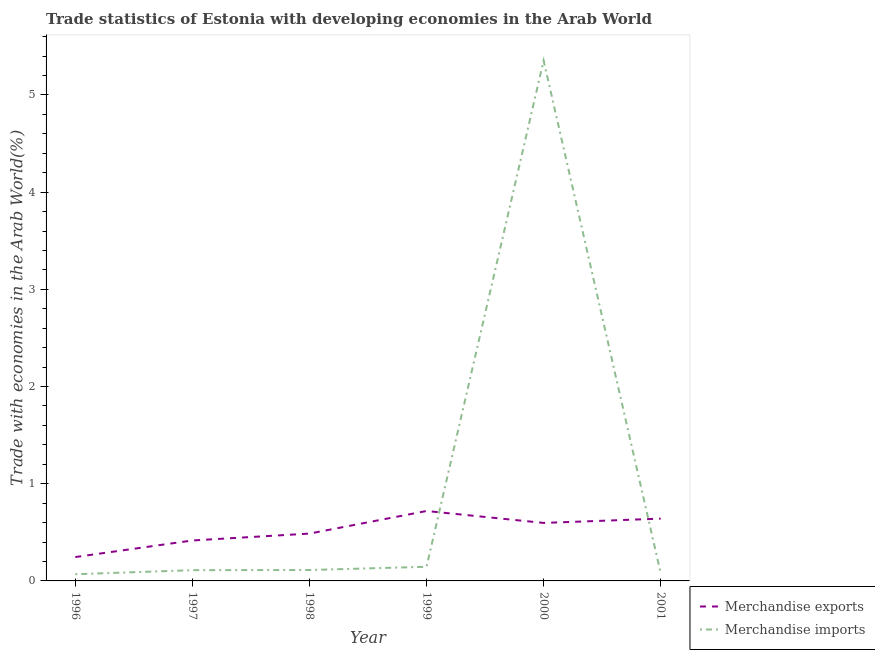How many different coloured lines are there?
Offer a terse response. 2. Does the line corresponding to merchandise exports intersect with the line corresponding to merchandise imports?
Give a very brief answer. Yes. Is the number of lines equal to the number of legend labels?
Keep it short and to the point. Yes. What is the merchandise exports in 2001?
Keep it short and to the point. 0.64. Across all years, what is the maximum merchandise exports?
Give a very brief answer. 0.72. Across all years, what is the minimum merchandise exports?
Your answer should be compact. 0.25. What is the total merchandise exports in the graph?
Provide a succinct answer. 3.11. What is the difference between the merchandise imports in 1996 and that in 2001?
Provide a short and direct response. -0.01. What is the difference between the merchandise imports in 1998 and the merchandise exports in 2000?
Offer a terse response. -0.48. What is the average merchandise exports per year?
Make the answer very short. 0.52. In the year 1999, what is the difference between the merchandise exports and merchandise imports?
Your response must be concise. 0.57. In how many years, is the merchandise imports greater than 3.8 %?
Offer a terse response. 1. What is the ratio of the merchandise imports in 1996 to that in 2000?
Offer a terse response. 0.01. Is the merchandise imports in 1998 less than that in 1999?
Keep it short and to the point. Yes. What is the difference between the highest and the second highest merchandise exports?
Offer a very short reply. 0.08. What is the difference between the highest and the lowest merchandise exports?
Provide a short and direct response. 0.47. Does the merchandise exports monotonically increase over the years?
Your response must be concise. No. Is the merchandise exports strictly less than the merchandise imports over the years?
Give a very brief answer. No. How many lines are there?
Provide a succinct answer. 2. How many years are there in the graph?
Your answer should be very brief. 6. What is the difference between two consecutive major ticks on the Y-axis?
Your answer should be compact. 1. Does the graph contain grids?
Make the answer very short. No. Where does the legend appear in the graph?
Offer a very short reply. Bottom right. How many legend labels are there?
Your response must be concise. 2. What is the title of the graph?
Keep it short and to the point. Trade statistics of Estonia with developing economies in the Arab World. What is the label or title of the Y-axis?
Give a very brief answer. Trade with economies in the Arab World(%). What is the Trade with economies in the Arab World(%) of Merchandise exports in 1996?
Offer a terse response. 0.25. What is the Trade with economies in the Arab World(%) in Merchandise imports in 1996?
Make the answer very short. 0.07. What is the Trade with economies in the Arab World(%) in Merchandise exports in 1997?
Your answer should be compact. 0.42. What is the Trade with economies in the Arab World(%) of Merchandise imports in 1997?
Your answer should be compact. 0.11. What is the Trade with economies in the Arab World(%) of Merchandise exports in 1998?
Offer a very short reply. 0.49. What is the Trade with economies in the Arab World(%) of Merchandise imports in 1998?
Provide a succinct answer. 0.11. What is the Trade with economies in the Arab World(%) in Merchandise exports in 1999?
Your answer should be very brief. 0.72. What is the Trade with economies in the Arab World(%) in Merchandise imports in 1999?
Make the answer very short. 0.15. What is the Trade with economies in the Arab World(%) of Merchandise exports in 2000?
Your answer should be very brief. 0.6. What is the Trade with economies in the Arab World(%) of Merchandise imports in 2000?
Offer a very short reply. 5.35. What is the Trade with economies in the Arab World(%) of Merchandise exports in 2001?
Your answer should be very brief. 0.64. What is the Trade with economies in the Arab World(%) of Merchandise imports in 2001?
Your response must be concise. 0.08. Across all years, what is the maximum Trade with economies in the Arab World(%) in Merchandise exports?
Offer a terse response. 0.72. Across all years, what is the maximum Trade with economies in the Arab World(%) of Merchandise imports?
Ensure brevity in your answer.  5.35. Across all years, what is the minimum Trade with economies in the Arab World(%) of Merchandise exports?
Provide a succinct answer. 0.25. Across all years, what is the minimum Trade with economies in the Arab World(%) in Merchandise imports?
Your answer should be compact. 0.07. What is the total Trade with economies in the Arab World(%) in Merchandise exports in the graph?
Your answer should be compact. 3.11. What is the total Trade with economies in the Arab World(%) in Merchandise imports in the graph?
Provide a succinct answer. 5.87. What is the difference between the Trade with economies in the Arab World(%) in Merchandise exports in 1996 and that in 1997?
Give a very brief answer. -0.17. What is the difference between the Trade with economies in the Arab World(%) of Merchandise imports in 1996 and that in 1997?
Provide a succinct answer. -0.04. What is the difference between the Trade with economies in the Arab World(%) in Merchandise exports in 1996 and that in 1998?
Your answer should be compact. -0.24. What is the difference between the Trade with economies in the Arab World(%) of Merchandise imports in 1996 and that in 1998?
Provide a succinct answer. -0.04. What is the difference between the Trade with economies in the Arab World(%) in Merchandise exports in 1996 and that in 1999?
Offer a terse response. -0.47. What is the difference between the Trade with economies in the Arab World(%) of Merchandise imports in 1996 and that in 1999?
Make the answer very short. -0.08. What is the difference between the Trade with economies in the Arab World(%) in Merchandise exports in 1996 and that in 2000?
Provide a succinct answer. -0.35. What is the difference between the Trade with economies in the Arab World(%) of Merchandise imports in 1996 and that in 2000?
Make the answer very short. -5.29. What is the difference between the Trade with economies in the Arab World(%) in Merchandise exports in 1996 and that in 2001?
Provide a succinct answer. -0.4. What is the difference between the Trade with economies in the Arab World(%) in Merchandise imports in 1996 and that in 2001?
Your answer should be very brief. -0.01. What is the difference between the Trade with economies in the Arab World(%) in Merchandise exports in 1997 and that in 1998?
Ensure brevity in your answer.  -0.07. What is the difference between the Trade with economies in the Arab World(%) in Merchandise imports in 1997 and that in 1998?
Offer a terse response. -0. What is the difference between the Trade with economies in the Arab World(%) of Merchandise exports in 1997 and that in 1999?
Offer a terse response. -0.3. What is the difference between the Trade with economies in the Arab World(%) in Merchandise imports in 1997 and that in 1999?
Your answer should be very brief. -0.04. What is the difference between the Trade with economies in the Arab World(%) of Merchandise exports in 1997 and that in 2000?
Give a very brief answer. -0.18. What is the difference between the Trade with economies in the Arab World(%) of Merchandise imports in 1997 and that in 2000?
Ensure brevity in your answer.  -5.24. What is the difference between the Trade with economies in the Arab World(%) in Merchandise exports in 1997 and that in 2001?
Ensure brevity in your answer.  -0.22. What is the difference between the Trade with economies in the Arab World(%) in Merchandise exports in 1998 and that in 1999?
Your answer should be compact. -0.23. What is the difference between the Trade with economies in the Arab World(%) of Merchandise imports in 1998 and that in 1999?
Your answer should be compact. -0.03. What is the difference between the Trade with economies in the Arab World(%) in Merchandise exports in 1998 and that in 2000?
Give a very brief answer. -0.11. What is the difference between the Trade with economies in the Arab World(%) of Merchandise imports in 1998 and that in 2000?
Keep it short and to the point. -5.24. What is the difference between the Trade with economies in the Arab World(%) in Merchandise exports in 1998 and that in 2001?
Provide a succinct answer. -0.15. What is the difference between the Trade with economies in the Arab World(%) in Merchandise imports in 1998 and that in 2001?
Your response must be concise. 0.03. What is the difference between the Trade with economies in the Arab World(%) in Merchandise exports in 1999 and that in 2000?
Give a very brief answer. 0.12. What is the difference between the Trade with economies in the Arab World(%) of Merchandise imports in 1999 and that in 2000?
Give a very brief answer. -5.21. What is the difference between the Trade with economies in the Arab World(%) in Merchandise exports in 1999 and that in 2001?
Make the answer very short. 0.08. What is the difference between the Trade with economies in the Arab World(%) in Merchandise imports in 1999 and that in 2001?
Keep it short and to the point. 0.07. What is the difference between the Trade with economies in the Arab World(%) of Merchandise exports in 2000 and that in 2001?
Offer a very short reply. -0.04. What is the difference between the Trade with economies in the Arab World(%) of Merchandise imports in 2000 and that in 2001?
Provide a succinct answer. 5.27. What is the difference between the Trade with economies in the Arab World(%) of Merchandise exports in 1996 and the Trade with economies in the Arab World(%) of Merchandise imports in 1997?
Your answer should be very brief. 0.14. What is the difference between the Trade with economies in the Arab World(%) in Merchandise exports in 1996 and the Trade with economies in the Arab World(%) in Merchandise imports in 1998?
Give a very brief answer. 0.13. What is the difference between the Trade with economies in the Arab World(%) in Merchandise exports in 1996 and the Trade with economies in the Arab World(%) in Merchandise imports in 1999?
Keep it short and to the point. 0.1. What is the difference between the Trade with economies in the Arab World(%) in Merchandise exports in 1996 and the Trade with economies in the Arab World(%) in Merchandise imports in 2000?
Your response must be concise. -5.11. What is the difference between the Trade with economies in the Arab World(%) in Merchandise exports in 1996 and the Trade with economies in the Arab World(%) in Merchandise imports in 2001?
Provide a short and direct response. 0.17. What is the difference between the Trade with economies in the Arab World(%) of Merchandise exports in 1997 and the Trade with economies in the Arab World(%) of Merchandise imports in 1998?
Offer a terse response. 0.3. What is the difference between the Trade with economies in the Arab World(%) of Merchandise exports in 1997 and the Trade with economies in the Arab World(%) of Merchandise imports in 1999?
Offer a terse response. 0.27. What is the difference between the Trade with economies in the Arab World(%) of Merchandise exports in 1997 and the Trade with economies in the Arab World(%) of Merchandise imports in 2000?
Your response must be concise. -4.94. What is the difference between the Trade with economies in the Arab World(%) of Merchandise exports in 1997 and the Trade with economies in the Arab World(%) of Merchandise imports in 2001?
Offer a very short reply. 0.34. What is the difference between the Trade with economies in the Arab World(%) of Merchandise exports in 1998 and the Trade with economies in the Arab World(%) of Merchandise imports in 1999?
Ensure brevity in your answer.  0.34. What is the difference between the Trade with economies in the Arab World(%) in Merchandise exports in 1998 and the Trade with economies in the Arab World(%) in Merchandise imports in 2000?
Your response must be concise. -4.87. What is the difference between the Trade with economies in the Arab World(%) of Merchandise exports in 1998 and the Trade with economies in the Arab World(%) of Merchandise imports in 2001?
Offer a terse response. 0.41. What is the difference between the Trade with economies in the Arab World(%) in Merchandise exports in 1999 and the Trade with economies in the Arab World(%) in Merchandise imports in 2000?
Make the answer very short. -4.63. What is the difference between the Trade with economies in the Arab World(%) of Merchandise exports in 1999 and the Trade with economies in the Arab World(%) of Merchandise imports in 2001?
Provide a short and direct response. 0.64. What is the difference between the Trade with economies in the Arab World(%) of Merchandise exports in 2000 and the Trade with economies in the Arab World(%) of Merchandise imports in 2001?
Offer a terse response. 0.52. What is the average Trade with economies in the Arab World(%) of Merchandise exports per year?
Offer a terse response. 0.52. What is the average Trade with economies in the Arab World(%) of Merchandise imports per year?
Provide a short and direct response. 0.98. In the year 1996, what is the difference between the Trade with economies in the Arab World(%) of Merchandise exports and Trade with economies in the Arab World(%) of Merchandise imports?
Your answer should be very brief. 0.18. In the year 1997, what is the difference between the Trade with economies in the Arab World(%) of Merchandise exports and Trade with economies in the Arab World(%) of Merchandise imports?
Keep it short and to the point. 0.31. In the year 1998, what is the difference between the Trade with economies in the Arab World(%) in Merchandise exports and Trade with economies in the Arab World(%) in Merchandise imports?
Your response must be concise. 0.37. In the year 1999, what is the difference between the Trade with economies in the Arab World(%) of Merchandise exports and Trade with economies in the Arab World(%) of Merchandise imports?
Your response must be concise. 0.57. In the year 2000, what is the difference between the Trade with economies in the Arab World(%) of Merchandise exports and Trade with economies in the Arab World(%) of Merchandise imports?
Provide a short and direct response. -4.76. In the year 2001, what is the difference between the Trade with economies in the Arab World(%) of Merchandise exports and Trade with economies in the Arab World(%) of Merchandise imports?
Provide a succinct answer. 0.56. What is the ratio of the Trade with economies in the Arab World(%) in Merchandise exports in 1996 to that in 1997?
Offer a very short reply. 0.59. What is the ratio of the Trade with economies in the Arab World(%) of Merchandise imports in 1996 to that in 1997?
Make the answer very short. 0.62. What is the ratio of the Trade with economies in the Arab World(%) of Merchandise exports in 1996 to that in 1998?
Your answer should be compact. 0.5. What is the ratio of the Trade with economies in the Arab World(%) of Merchandise imports in 1996 to that in 1998?
Ensure brevity in your answer.  0.61. What is the ratio of the Trade with economies in the Arab World(%) of Merchandise exports in 1996 to that in 1999?
Offer a terse response. 0.34. What is the ratio of the Trade with economies in the Arab World(%) of Merchandise imports in 1996 to that in 1999?
Provide a short and direct response. 0.47. What is the ratio of the Trade with economies in the Arab World(%) in Merchandise exports in 1996 to that in 2000?
Provide a succinct answer. 0.41. What is the ratio of the Trade with economies in the Arab World(%) in Merchandise imports in 1996 to that in 2000?
Make the answer very short. 0.01. What is the ratio of the Trade with economies in the Arab World(%) of Merchandise exports in 1996 to that in 2001?
Keep it short and to the point. 0.38. What is the ratio of the Trade with economies in the Arab World(%) of Merchandise imports in 1996 to that in 2001?
Offer a terse response. 0.85. What is the ratio of the Trade with economies in the Arab World(%) in Merchandise exports in 1997 to that in 1998?
Your response must be concise. 0.85. What is the ratio of the Trade with economies in the Arab World(%) of Merchandise imports in 1997 to that in 1998?
Your response must be concise. 0.98. What is the ratio of the Trade with economies in the Arab World(%) of Merchandise exports in 1997 to that in 1999?
Make the answer very short. 0.58. What is the ratio of the Trade with economies in the Arab World(%) in Merchandise imports in 1997 to that in 1999?
Your response must be concise. 0.76. What is the ratio of the Trade with economies in the Arab World(%) of Merchandise exports in 1997 to that in 2000?
Your response must be concise. 0.7. What is the ratio of the Trade with economies in the Arab World(%) of Merchandise imports in 1997 to that in 2000?
Your response must be concise. 0.02. What is the ratio of the Trade with economies in the Arab World(%) of Merchandise exports in 1997 to that in 2001?
Give a very brief answer. 0.65. What is the ratio of the Trade with economies in the Arab World(%) in Merchandise imports in 1997 to that in 2001?
Provide a short and direct response. 1.37. What is the ratio of the Trade with economies in the Arab World(%) in Merchandise exports in 1998 to that in 1999?
Provide a short and direct response. 0.68. What is the ratio of the Trade with economies in the Arab World(%) in Merchandise imports in 1998 to that in 1999?
Your response must be concise. 0.77. What is the ratio of the Trade with economies in the Arab World(%) in Merchandise exports in 1998 to that in 2000?
Ensure brevity in your answer.  0.82. What is the ratio of the Trade with economies in the Arab World(%) of Merchandise imports in 1998 to that in 2000?
Make the answer very short. 0.02. What is the ratio of the Trade with economies in the Arab World(%) of Merchandise exports in 1998 to that in 2001?
Keep it short and to the point. 0.76. What is the ratio of the Trade with economies in the Arab World(%) in Merchandise imports in 1998 to that in 2001?
Provide a short and direct response. 1.39. What is the ratio of the Trade with economies in the Arab World(%) in Merchandise exports in 1999 to that in 2000?
Provide a succinct answer. 1.21. What is the ratio of the Trade with economies in the Arab World(%) of Merchandise imports in 1999 to that in 2000?
Give a very brief answer. 0.03. What is the ratio of the Trade with economies in the Arab World(%) of Merchandise exports in 1999 to that in 2001?
Keep it short and to the point. 1.12. What is the ratio of the Trade with economies in the Arab World(%) in Merchandise imports in 1999 to that in 2001?
Offer a very short reply. 1.81. What is the ratio of the Trade with economies in the Arab World(%) of Merchandise exports in 2000 to that in 2001?
Provide a short and direct response. 0.93. What is the ratio of the Trade with economies in the Arab World(%) of Merchandise imports in 2000 to that in 2001?
Provide a succinct answer. 66.52. What is the difference between the highest and the second highest Trade with economies in the Arab World(%) in Merchandise exports?
Provide a succinct answer. 0.08. What is the difference between the highest and the second highest Trade with economies in the Arab World(%) in Merchandise imports?
Ensure brevity in your answer.  5.21. What is the difference between the highest and the lowest Trade with economies in the Arab World(%) in Merchandise exports?
Make the answer very short. 0.47. What is the difference between the highest and the lowest Trade with economies in the Arab World(%) in Merchandise imports?
Your answer should be very brief. 5.29. 